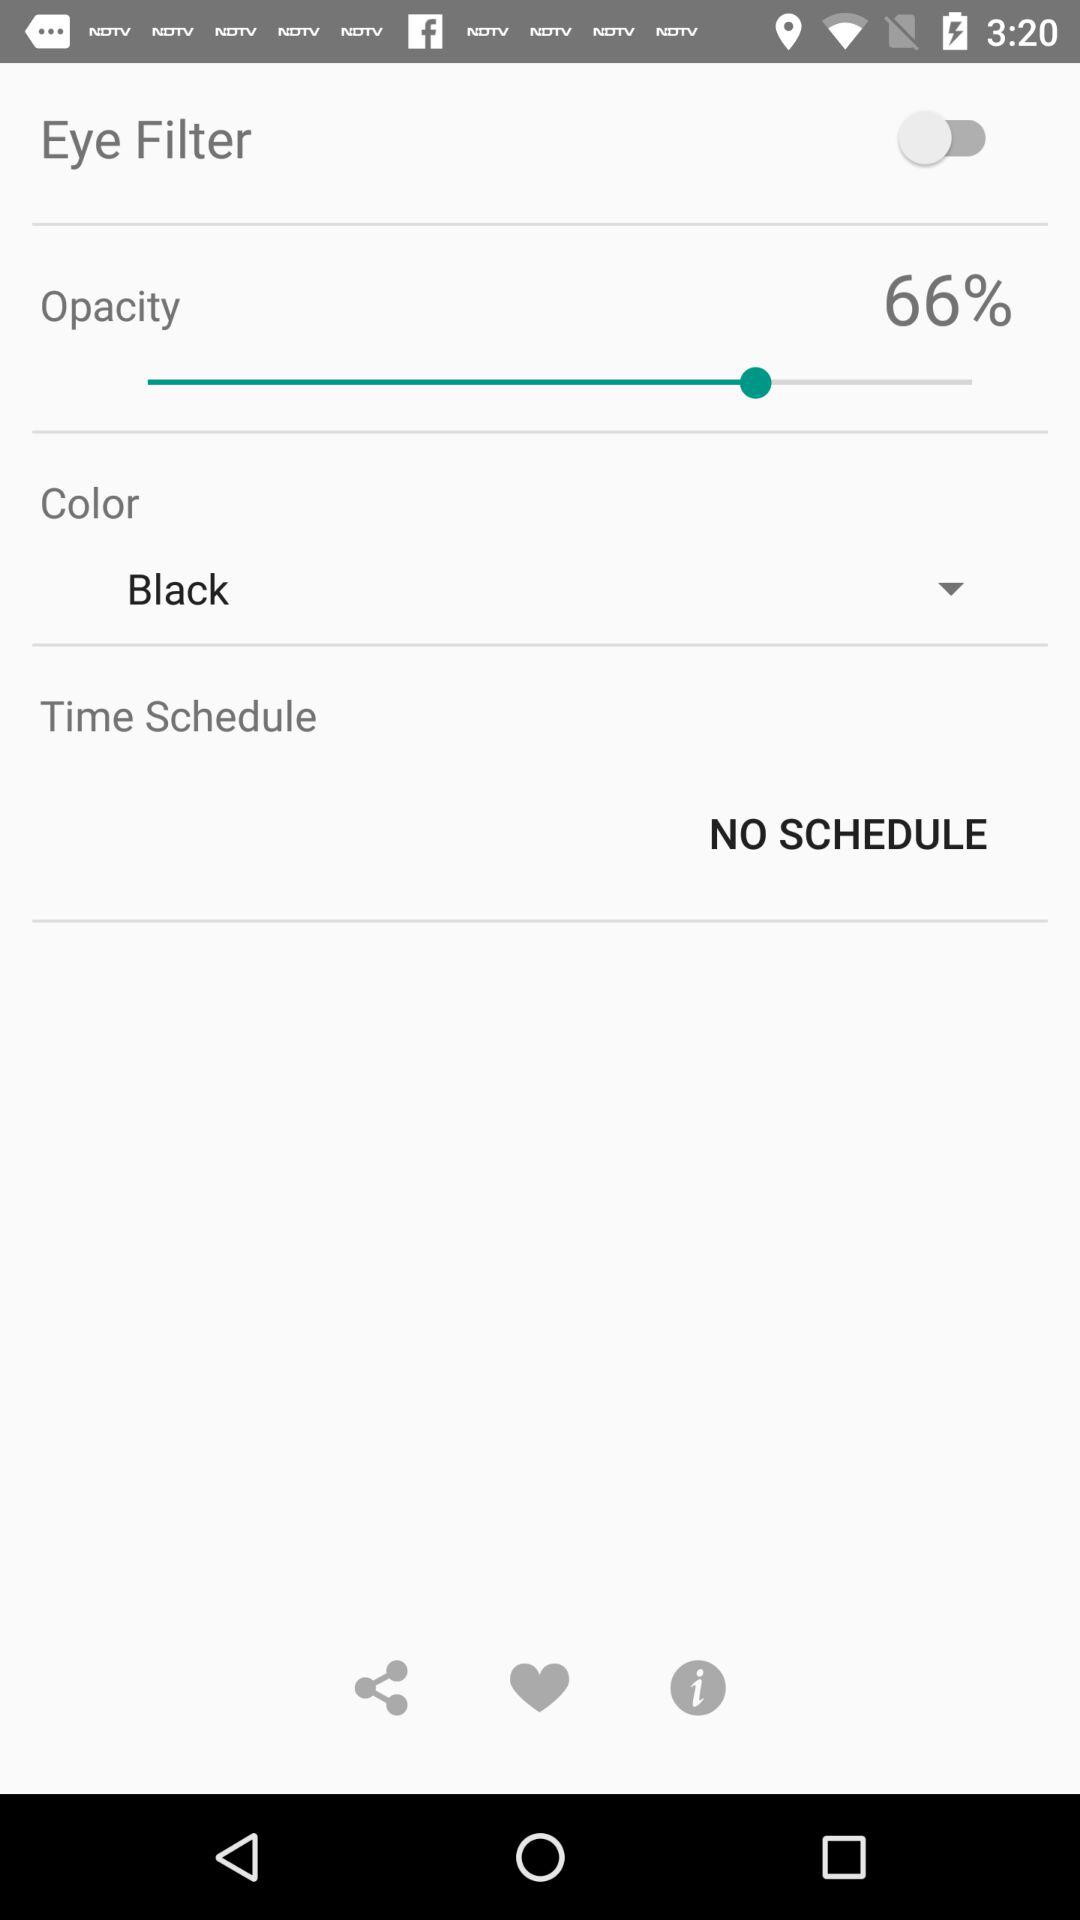Which color has been selected? The selected color is black. 